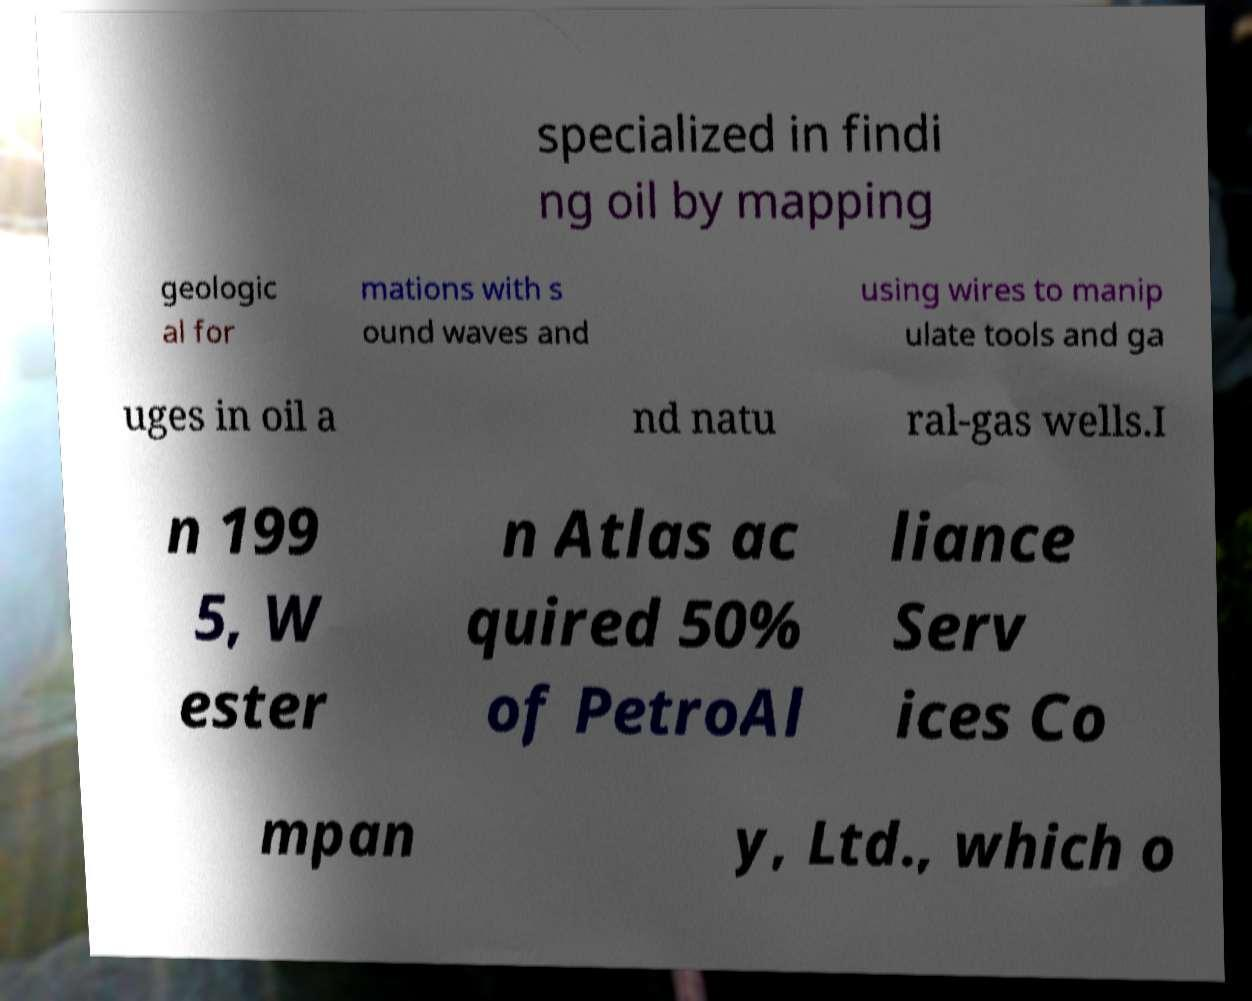Can you read and provide the text displayed in the image?This photo seems to have some interesting text. Can you extract and type it out for me? specialized in findi ng oil by mapping geologic al for mations with s ound waves and using wires to manip ulate tools and ga uges in oil a nd natu ral-gas wells.I n 199 5, W ester n Atlas ac quired 50% of PetroAl liance Serv ices Co mpan y, Ltd., which o 